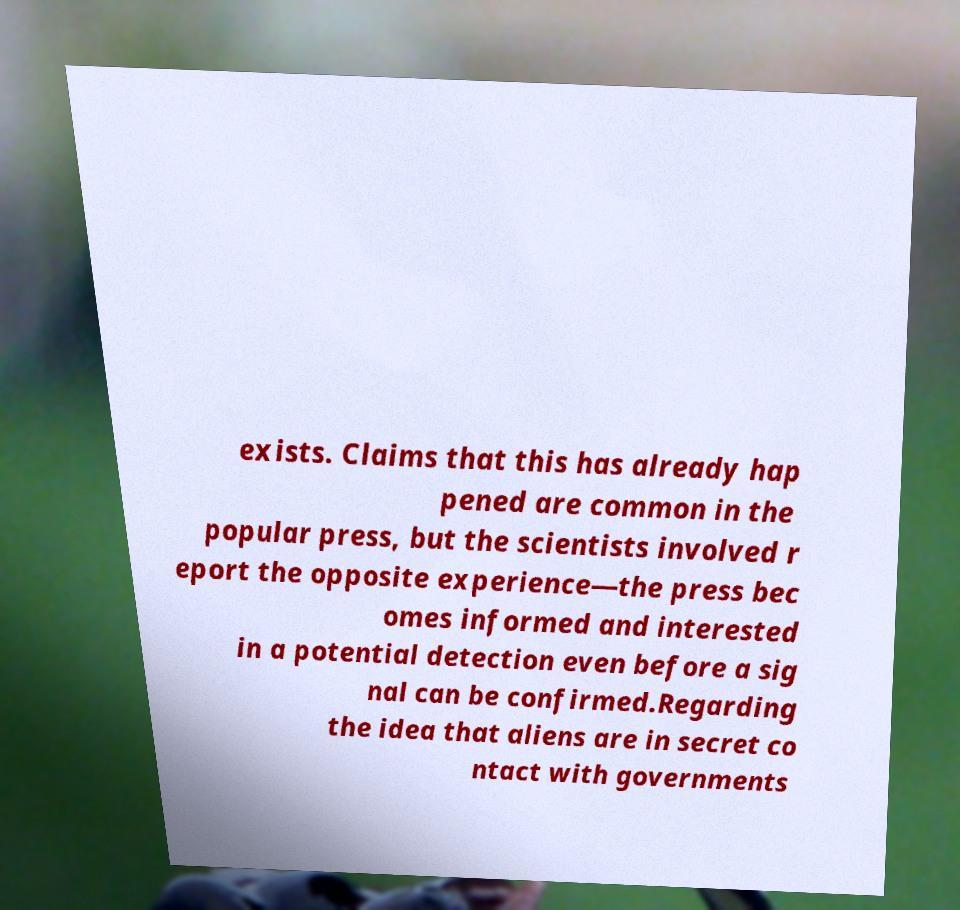Could you extract and type out the text from this image? exists. Claims that this has already hap pened are common in the popular press, but the scientists involved r eport the opposite experience—the press bec omes informed and interested in a potential detection even before a sig nal can be confirmed.Regarding the idea that aliens are in secret co ntact with governments 